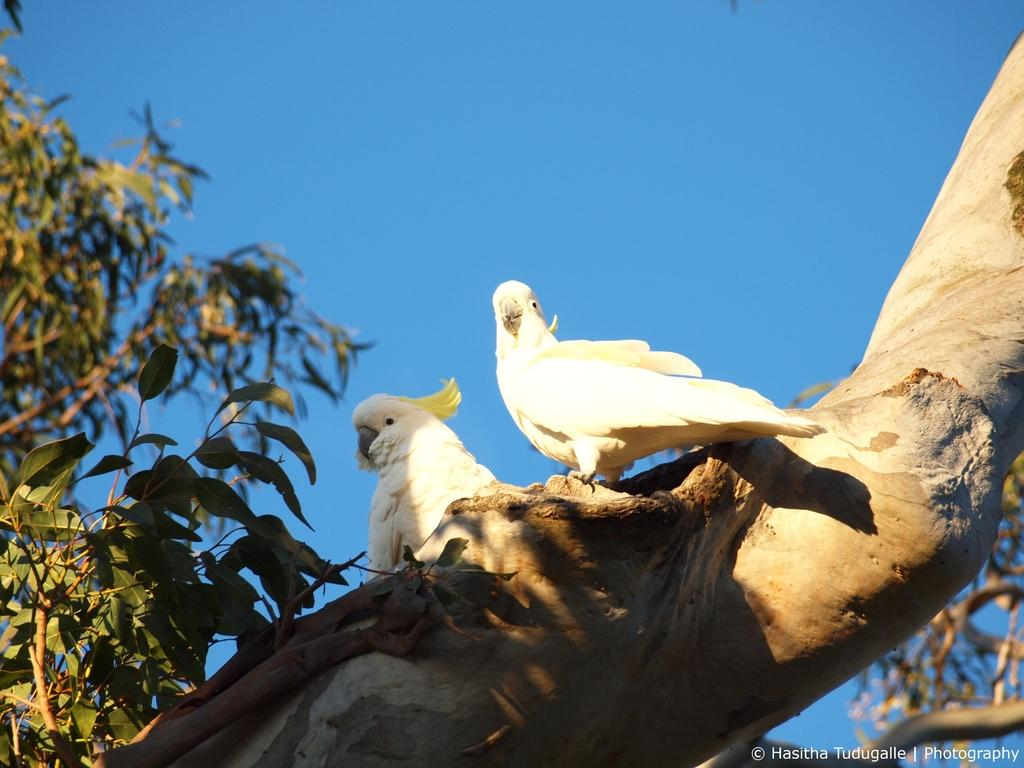What is the main subject in the front of the image? There is a tree trunk in the front of the image. What are the birds doing on the tree trunk? The birds are standing on the tree trunk. What can be seen in the background of the image? There are leaves visible in the background of the image. How many apples are hanging from the tree trunk in the image? There are no apples present in the image; it features a tree trunk with birds standing on it. What type of thumb can be seen interacting with the birds on the tree trunk? There is no thumb visible in the image; it only shows birds standing on the tree trunk. 